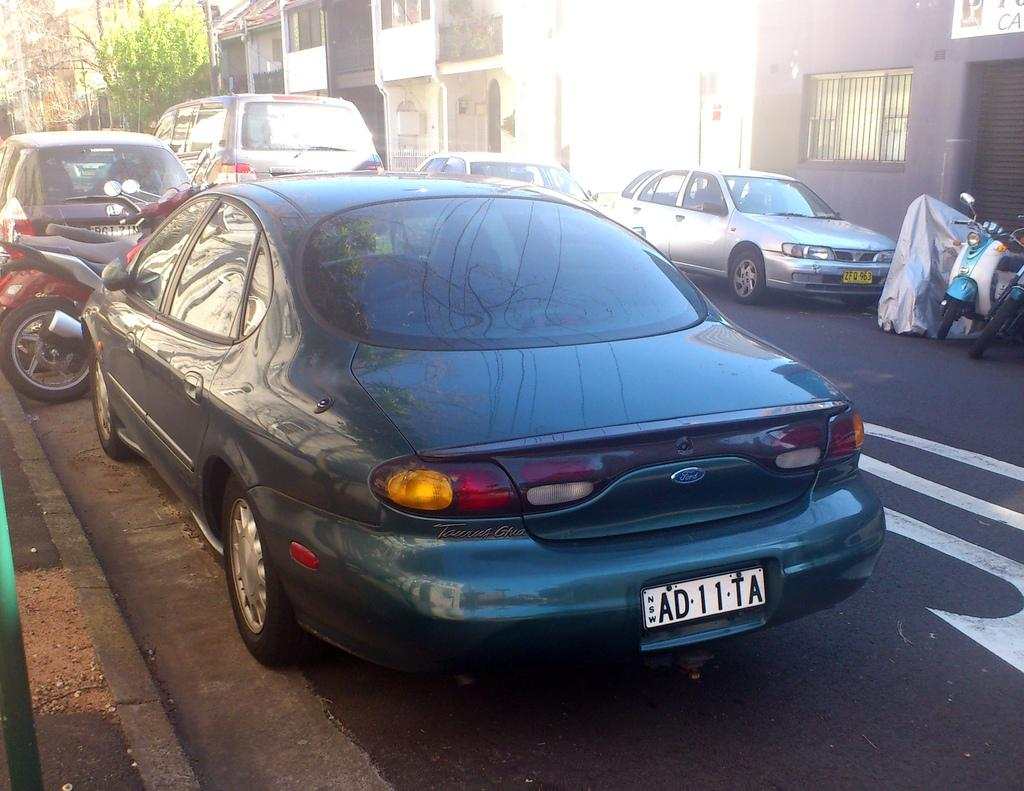What is happening on the road in the image? There are vehicles on the road in the image. What can be seen in the distance behind the vehicles? There are buildings and trees visible in the background of the image. What type of wood can be seen in the image? There is no wood present in the image; it features vehicles on the road and buildings and trees in the background. 